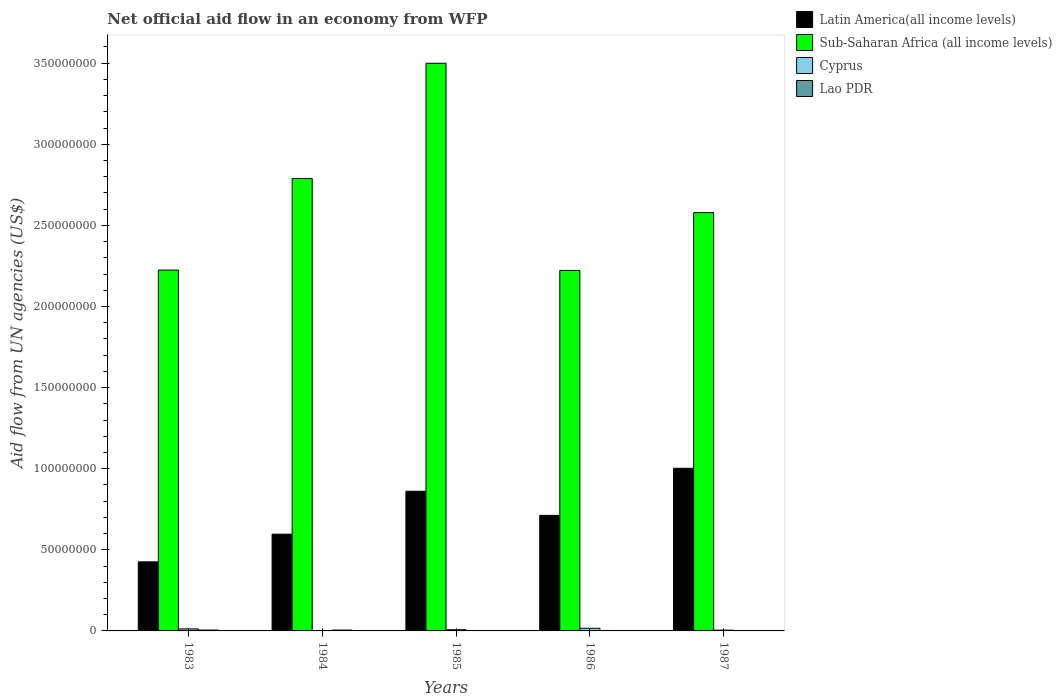How many different coloured bars are there?
Your answer should be compact. 4. How many groups of bars are there?
Provide a short and direct response. 5. What is the label of the 4th group of bars from the left?
Your response must be concise. 1986. In how many cases, is the number of bars for a given year not equal to the number of legend labels?
Your answer should be compact. 0. What is the net official aid flow in Cyprus in 1985?
Ensure brevity in your answer.  7.40e+05. Across all years, what is the maximum net official aid flow in Cyprus?
Offer a terse response. 1.63e+06. Across all years, what is the minimum net official aid flow in Cyprus?
Your answer should be compact. 2.20e+05. In which year was the net official aid flow in Sub-Saharan Africa (all income levels) minimum?
Give a very brief answer. 1986. What is the total net official aid flow in Lao PDR in the graph?
Your answer should be compact. 1.74e+06. What is the difference between the net official aid flow in Sub-Saharan Africa (all income levels) in 1983 and that in 1984?
Keep it short and to the point. -5.64e+07. What is the difference between the net official aid flow in Latin America(all income levels) in 1987 and the net official aid flow in Lao PDR in 1985?
Give a very brief answer. 1.00e+08. What is the average net official aid flow in Latin America(all income levels) per year?
Your response must be concise. 7.20e+07. In the year 1987, what is the difference between the net official aid flow in Latin America(all income levels) and net official aid flow in Sub-Saharan Africa (all income levels)?
Ensure brevity in your answer.  -1.58e+08. In how many years, is the net official aid flow in Sub-Saharan Africa (all income levels) greater than 50000000 US$?
Keep it short and to the point. 5. What is the ratio of the net official aid flow in Latin America(all income levels) in 1983 to that in 1987?
Provide a succinct answer. 0.42. Is the difference between the net official aid flow in Latin America(all income levels) in 1985 and 1987 greater than the difference between the net official aid flow in Sub-Saharan Africa (all income levels) in 1985 and 1987?
Your answer should be compact. No. What is the difference between the highest and the second highest net official aid flow in Lao PDR?
Provide a short and direct response. 10000. In how many years, is the net official aid flow in Latin America(all income levels) greater than the average net official aid flow in Latin America(all income levels) taken over all years?
Your response must be concise. 2. Is the sum of the net official aid flow in Sub-Saharan Africa (all income levels) in 1983 and 1984 greater than the maximum net official aid flow in Cyprus across all years?
Provide a succinct answer. Yes. What does the 3rd bar from the left in 1984 represents?
Give a very brief answer. Cyprus. What does the 1st bar from the right in 1983 represents?
Provide a short and direct response. Lao PDR. Is it the case that in every year, the sum of the net official aid flow in Latin America(all income levels) and net official aid flow in Cyprus is greater than the net official aid flow in Sub-Saharan Africa (all income levels)?
Your answer should be very brief. No. How many bars are there?
Make the answer very short. 20. Are all the bars in the graph horizontal?
Ensure brevity in your answer.  No. What is the difference between two consecutive major ticks on the Y-axis?
Ensure brevity in your answer.  5.00e+07. Are the values on the major ticks of Y-axis written in scientific E-notation?
Provide a succinct answer. No. Does the graph contain any zero values?
Make the answer very short. No. Where does the legend appear in the graph?
Provide a succinct answer. Top right. How many legend labels are there?
Make the answer very short. 4. How are the legend labels stacked?
Your response must be concise. Vertical. What is the title of the graph?
Keep it short and to the point. Net official aid flow in an economy from WFP. Does "Sint Maarten (Dutch part)" appear as one of the legend labels in the graph?
Ensure brevity in your answer.  No. What is the label or title of the X-axis?
Make the answer very short. Years. What is the label or title of the Y-axis?
Offer a terse response. Aid flow from UN agencies (US$). What is the Aid flow from UN agencies (US$) of Latin America(all income levels) in 1983?
Keep it short and to the point. 4.26e+07. What is the Aid flow from UN agencies (US$) in Sub-Saharan Africa (all income levels) in 1983?
Make the answer very short. 2.22e+08. What is the Aid flow from UN agencies (US$) in Cyprus in 1983?
Give a very brief answer. 1.25e+06. What is the Aid flow from UN agencies (US$) of Lao PDR in 1983?
Make the answer very short. 5.30e+05. What is the Aid flow from UN agencies (US$) of Latin America(all income levels) in 1984?
Make the answer very short. 5.96e+07. What is the Aid flow from UN agencies (US$) of Sub-Saharan Africa (all income levels) in 1984?
Make the answer very short. 2.79e+08. What is the Aid flow from UN agencies (US$) in Lao PDR in 1984?
Provide a succinct answer. 5.20e+05. What is the Aid flow from UN agencies (US$) in Latin America(all income levels) in 1985?
Give a very brief answer. 8.61e+07. What is the Aid flow from UN agencies (US$) of Sub-Saharan Africa (all income levels) in 1985?
Make the answer very short. 3.50e+08. What is the Aid flow from UN agencies (US$) in Cyprus in 1985?
Provide a short and direct response. 7.40e+05. What is the Aid flow from UN agencies (US$) of Latin America(all income levels) in 1986?
Your answer should be compact. 7.12e+07. What is the Aid flow from UN agencies (US$) of Sub-Saharan Africa (all income levels) in 1986?
Your response must be concise. 2.22e+08. What is the Aid flow from UN agencies (US$) in Cyprus in 1986?
Provide a succinct answer. 1.63e+06. What is the Aid flow from UN agencies (US$) in Lao PDR in 1986?
Ensure brevity in your answer.  2.60e+05. What is the Aid flow from UN agencies (US$) in Latin America(all income levels) in 1987?
Your answer should be very brief. 1.00e+08. What is the Aid flow from UN agencies (US$) in Sub-Saharan Africa (all income levels) in 1987?
Ensure brevity in your answer.  2.58e+08. What is the Aid flow from UN agencies (US$) in Cyprus in 1987?
Make the answer very short. 4.80e+05. Across all years, what is the maximum Aid flow from UN agencies (US$) of Latin America(all income levels)?
Offer a terse response. 1.00e+08. Across all years, what is the maximum Aid flow from UN agencies (US$) in Sub-Saharan Africa (all income levels)?
Your answer should be very brief. 3.50e+08. Across all years, what is the maximum Aid flow from UN agencies (US$) of Cyprus?
Provide a succinct answer. 1.63e+06. Across all years, what is the maximum Aid flow from UN agencies (US$) in Lao PDR?
Provide a short and direct response. 5.30e+05. Across all years, what is the minimum Aid flow from UN agencies (US$) of Latin America(all income levels)?
Offer a very short reply. 4.26e+07. Across all years, what is the minimum Aid flow from UN agencies (US$) in Sub-Saharan Africa (all income levels)?
Provide a succinct answer. 2.22e+08. What is the total Aid flow from UN agencies (US$) in Latin America(all income levels) in the graph?
Provide a succinct answer. 3.60e+08. What is the total Aid flow from UN agencies (US$) of Sub-Saharan Africa (all income levels) in the graph?
Offer a terse response. 1.33e+09. What is the total Aid flow from UN agencies (US$) of Cyprus in the graph?
Provide a succinct answer. 4.32e+06. What is the total Aid flow from UN agencies (US$) in Lao PDR in the graph?
Provide a short and direct response. 1.74e+06. What is the difference between the Aid flow from UN agencies (US$) of Latin America(all income levels) in 1983 and that in 1984?
Ensure brevity in your answer.  -1.71e+07. What is the difference between the Aid flow from UN agencies (US$) in Sub-Saharan Africa (all income levels) in 1983 and that in 1984?
Keep it short and to the point. -5.64e+07. What is the difference between the Aid flow from UN agencies (US$) of Cyprus in 1983 and that in 1984?
Provide a short and direct response. 1.03e+06. What is the difference between the Aid flow from UN agencies (US$) in Lao PDR in 1983 and that in 1984?
Keep it short and to the point. 10000. What is the difference between the Aid flow from UN agencies (US$) of Latin America(all income levels) in 1983 and that in 1985?
Ensure brevity in your answer.  -4.35e+07. What is the difference between the Aid flow from UN agencies (US$) in Sub-Saharan Africa (all income levels) in 1983 and that in 1985?
Make the answer very short. -1.27e+08. What is the difference between the Aid flow from UN agencies (US$) in Cyprus in 1983 and that in 1985?
Give a very brief answer. 5.10e+05. What is the difference between the Aid flow from UN agencies (US$) in Lao PDR in 1983 and that in 1985?
Offer a very short reply. 3.50e+05. What is the difference between the Aid flow from UN agencies (US$) of Latin America(all income levels) in 1983 and that in 1986?
Make the answer very short. -2.87e+07. What is the difference between the Aid flow from UN agencies (US$) of Sub-Saharan Africa (all income levels) in 1983 and that in 1986?
Your response must be concise. 2.30e+05. What is the difference between the Aid flow from UN agencies (US$) of Cyprus in 1983 and that in 1986?
Your response must be concise. -3.80e+05. What is the difference between the Aid flow from UN agencies (US$) of Lao PDR in 1983 and that in 1986?
Your answer should be compact. 2.70e+05. What is the difference between the Aid flow from UN agencies (US$) in Latin America(all income levels) in 1983 and that in 1987?
Provide a succinct answer. -5.77e+07. What is the difference between the Aid flow from UN agencies (US$) of Sub-Saharan Africa (all income levels) in 1983 and that in 1987?
Your answer should be compact. -3.54e+07. What is the difference between the Aid flow from UN agencies (US$) of Cyprus in 1983 and that in 1987?
Make the answer very short. 7.70e+05. What is the difference between the Aid flow from UN agencies (US$) of Latin America(all income levels) in 1984 and that in 1985?
Give a very brief answer. -2.65e+07. What is the difference between the Aid flow from UN agencies (US$) of Sub-Saharan Africa (all income levels) in 1984 and that in 1985?
Provide a succinct answer. -7.10e+07. What is the difference between the Aid flow from UN agencies (US$) in Cyprus in 1984 and that in 1985?
Your answer should be compact. -5.20e+05. What is the difference between the Aid flow from UN agencies (US$) of Lao PDR in 1984 and that in 1985?
Keep it short and to the point. 3.40e+05. What is the difference between the Aid flow from UN agencies (US$) in Latin America(all income levels) in 1984 and that in 1986?
Your answer should be compact. -1.16e+07. What is the difference between the Aid flow from UN agencies (US$) in Sub-Saharan Africa (all income levels) in 1984 and that in 1986?
Your response must be concise. 5.67e+07. What is the difference between the Aid flow from UN agencies (US$) in Cyprus in 1984 and that in 1986?
Your answer should be very brief. -1.41e+06. What is the difference between the Aid flow from UN agencies (US$) in Latin America(all income levels) in 1984 and that in 1987?
Ensure brevity in your answer.  -4.06e+07. What is the difference between the Aid flow from UN agencies (US$) of Sub-Saharan Africa (all income levels) in 1984 and that in 1987?
Provide a short and direct response. 2.11e+07. What is the difference between the Aid flow from UN agencies (US$) in Cyprus in 1984 and that in 1987?
Provide a short and direct response. -2.60e+05. What is the difference between the Aid flow from UN agencies (US$) in Lao PDR in 1984 and that in 1987?
Offer a terse response. 2.70e+05. What is the difference between the Aid flow from UN agencies (US$) of Latin America(all income levels) in 1985 and that in 1986?
Make the answer very short. 1.49e+07. What is the difference between the Aid flow from UN agencies (US$) in Sub-Saharan Africa (all income levels) in 1985 and that in 1986?
Offer a terse response. 1.28e+08. What is the difference between the Aid flow from UN agencies (US$) of Cyprus in 1985 and that in 1986?
Provide a succinct answer. -8.90e+05. What is the difference between the Aid flow from UN agencies (US$) in Latin America(all income levels) in 1985 and that in 1987?
Your answer should be very brief. -1.42e+07. What is the difference between the Aid flow from UN agencies (US$) of Sub-Saharan Africa (all income levels) in 1985 and that in 1987?
Offer a very short reply. 9.21e+07. What is the difference between the Aid flow from UN agencies (US$) in Latin America(all income levels) in 1986 and that in 1987?
Offer a very short reply. -2.90e+07. What is the difference between the Aid flow from UN agencies (US$) of Sub-Saharan Africa (all income levels) in 1986 and that in 1987?
Provide a short and direct response. -3.56e+07. What is the difference between the Aid flow from UN agencies (US$) of Cyprus in 1986 and that in 1987?
Ensure brevity in your answer.  1.15e+06. What is the difference between the Aid flow from UN agencies (US$) of Latin America(all income levels) in 1983 and the Aid flow from UN agencies (US$) of Sub-Saharan Africa (all income levels) in 1984?
Offer a terse response. -2.36e+08. What is the difference between the Aid flow from UN agencies (US$) of Latin America(all income levels) in 1983 and the Aid flow from UN agencies (US$) of Cyprus in 1984?
Provide a succinct answer. 4.24e+07. What is the difference between the Aid flow from UN agencies (US$) in Latin America(all income levels) in 1983 and the Aid flow from UN agencies (US$) in Lao PDR in 1984?
Provide a succinct answer. 4.21e+07. What is the difference between the Aid flow from UN agencies (US$) in Sub-Saharan Africa (all income levels) in 1983 and the Aid flow from UN agencies (US$) in Cyprus in 1984?
Offer a very short reply. 2.22e+08. What is the difference between the Aid flow from UN agencies (US$) of Sub-Saharan Africa (all income levels) in 1983 and the Aid flow from UN agencies (US$) of Lao PDR in 1984?
Your answer should be compact. 2.22e+08. What is the difference between the Aid flow from UN agencies (US$) in Cyprus in 1983 and the Aid flow from UN agencies (US$) in Lao PDR in 1984?
Provide a succinct answer. 7.30e+05. What is the difference between the Aid flow from UN agencies (US$) of Latin America(all income levels) in 1983 and the Aid flow from UN agencies (US$) of Sub-Saharan Africa (all income levels) in 1985?
Your answer should be compact. -3.07e+08. What is the difference between the Aid flow from UN agencies (US$) of Latin America(all income levels) in 1983 and the Aid flow from UN agencies (US$) of Cyprus in 1985?
Provide a short and direct response. 4.18e+07. What is the difference between the Aid flow from UN agencies (US$) in Latin America(all income levels) in 1983 and the Aid flow from UN agencies (US$) in Lao PDR in 1985?
Provide a succinct answer. 4.24e+07. What is the difference between the Aid flow from UN agencies (US$) of Sub-Saharan Africa (all income levels) in 1983 and the Aid flow from UN agencies (US$) of Cyprus in 1985?
Your response must be concise. 2.22e+08. What is the difference between the Aid flow from UN agencies (US$) of Sub-Saharan Africa (all income levels) in 1983 and the Aid flow from UN agencies (US$) of Lao PDR in 1985?
Make the answer very short. 2.22e+08. What is the difference between the Aid flow from UN agencies (US$) of Cyprus in 1983 and the Aid flow from UN agencies (US$) of Lao PDR in 1985?
Your answer should be very brief. 1.07e+06. What is the difference between the Aid flow from UN agencies (US$) of Latin America(all income levels) in 1983 and the Aid flow from UN agencies (US$) of Sub-Saharan Africa (all income levels) in 1986?
Your answer should be compact. -1.80e+08. What is the difference between the Aid flow from UN agencies (US$) of Latin America(all income levels) in 1983 and the Aid flow from UN agencies (US$) of Cyprus in 1986?
Keep it short and to the point. 4.10e+07. What is the difference between the Aid flow from UN agencies (US$) in Latin America(all income levels) in 1983 and the Aid flow from UN agencies (US$) in Lao PDR in 1986?
Your answer should be compact. 4.23e+07. What is the difference between the Aid flow from UN agencies (US$) in Sub-Saharan Africa (all income levels) in 1983 and the Aid flow from UN agencies (US$) in Cyprus in 1986?
Make the answer very short. 2.21e+08. What is the difference between the Aid flow from UN agencies (US$) in Sub-Saharan Africa (all income levels) in 1983 and the Aid flow from UN agencies (US$) in Lao PDR in 1986?
Provide a short and direct response. 2.22e+08. What is the difference between the Aid flow from UN agencies (US$) of Cyprus in 1983 and the Aid flow from UN agencies (US$) of Lao PDR in 1986?
Your answer should be compact. 9.90e+05. What is the difference between the Aid flow from UN agencies (US$) of Latin America(all income levels) in 1983 and the Aid flow from UN agencies (US$) of Sub-Saharan Africa (all income levels) in 1987?
Keep it short and to the point. -2.15e+08. What is the difference between the Aid flow from UN agencies (US$) of Latin America(all income levels) in 1983 and the Aid flow from UN agencies (US$) of Cyprus in 1987?
Your response must be concise. 4.21e+07. What is the difference between the Aid flow from UN agencies (US$) in Latin America(all income levels) in 1983 and the Aid flow from UN agencies (US$) in Lao PDR in 1987?
Give a very brief answer. 4.23e+07. What is the difference between the Aid flow from UN agencies (US$) in Sub-Saharan Africa (all income levels) in 1983 and the Aid flow from UN agencies (US$) in Cyprus in 1987?
Offer a terse response. 2.22e+08. What is the difference between the Aid flow from UN agencies (US$) in Sub-Saharan Africa (all income levels) in 1983 and the Aid flow from UN agencies (US$) in Lao PDR in 1987?
Make the answer very short. 2.22e+08. What is the difference between the Aid flow from UN agencies (US$) of Latin America(all income levels) in 1984 and the Aid flow from UN agencies (US$) of Sub-Saharan Africa (all income levels) in 1985?
Provide a short and direct response. -2.90e+08. What is the difference between the Aid flow from UN agencies (US$) of Latin America(all income levels) in 1984 and the Aid flow from UN agencies (US$) of Cyprus in 1985?
Ensure brevity in your answer.  5.89e+07. What is the difference between the Aid flow from UN agencies (US$) of Latin America(all income levels) in 1984 and the Aid flow from UN agencies (US$) of Lao PDR in 1985?
Provide a succinct answer. 5.95e+07. What is the difference between the Aid flow from UN agencies (US$) in Sub-Saharan Africa (all income levels) in 1984 and the Aid flow from UN agencies (US$) in Cyprus in 1985?
Keep it short and to the point. 2.78e+08. What is the difference between the Aid flow from UN agencies (US$) in Sub-Saharan Africa (all income levels) in 1984 and the Aid flow from UN agencies (US$) in Lao PDR in 1985?
Ensure brevity in your answer.  2.79e+08. What is the difference between the Aid flow from UN agencies (US$) in Cyprus in 1984 and the Aid flow from UN agencies (US$) in Lao PDR in 1985?
Give a very brief answer. 4.00e+04. What is the difference between the Aid flow from UN agencies (US$) in Latin America(all income levels) in 1984 and the Aid flow from UN agencies (US$) in Sub-Saharan Africa (all income levels) in 1986?
Provide a short and direct response. -1.63e+08. What is the difference between the Aid flow from UN agencies (US$) of Latin America(all income levels) in 1984 and the Aid flow from UN agencies (US$) of Cyprus in 1986?
Make the answer very short. 5.80e+07. What is the difference between the Aid flow from UN agencies (US$) of Latin America(all income levels) in 1984 and the Aid flow from UN agencies (US$) of Lao PDR in 1986?
Your response must be concise. 5.94e+07. What is the difference between the Aid flow from UN agencies (US$) in Sub-Saharan Africa (all income levels) in 1984 and the Aid flow from UN agencies (US$) in Cyprus in 1986?
Keep it short and to the point. 2.77e+08. What is the difference between the Aid flow from UN agencies (US$) of Sub-Saharan Africa (all income levels) in 1984 and the Aid flow from UN agencies (US$) of Lao PDR in 1986?
Give a very brief answer. 2.79e+08. What is the difference between the Aid flow from UN agencies (US$) in Latin America(all income levels) in 1984 and the Aid flow from UN agencies (US$) in Sub-Saharan Africa (all income levels) in 1987?
Keep it short and to the point. -1.98e+08. What is the difference between the Aid flow from UN agencies (US$) in Latin America(all income levels) in 1984 and the Aid flow from UN agencies (US$) in Cyprus in 1987?
Offer a very short reply. 5.92e+07. What is the difference between the Aid flow from UN agencies (US$) in Latin America(all income levels) in 1984 and the Aid flow from UN agencies (US$) in Lao PDR in 1987?
Offer a very short reply. 5.94e+07. What is the difference between the Aid flow from UN agencies (US$) of Sub-Saharan Africa (all income levels) in 1984 and the Aid flow from UN agencies (US$) of Cyprus in 1987?
Your answer should be compact. 2.78e+08. What is the difference between the Aid flow from UN agencies (US$) in Sub-Saharan Africa (all income levels) in 1984 and the Aid flow from UN agencies (US$) in Lao PDR in 1987?
Offer a terse response. 2.79e+08. What is the difference between the Aid flow from UN agencies (US$) of Cyprus in 1984 and the Aid flow from UN agencies (US$) of Lao PDR in 1987?
Provide a short and direct response. -3.00e+04. What is the difference between the Aid flow from UN agencies (US$) of Latin America(all income levels) in 1985 and the Aid flow from UN agencies (US$) of Sub-Saharan Africa (all income levels) in 1986?
Your answer should be very brief. -1.36e+08. What is the difference between the Aid flow from UN agencies (US$) of Latin America(all income levels) in 1985 and the Aid flow from UN agencies (US$) of Cyprus in 1986?
Keep it short and to the point. 8.45e+07. What is the difference between the Aid flow from UN agencies (US$) in Latin America(all income levels) in 1985 and the Aid flow from UN agencies (US$) in Lao PDR in 1986?
Offer a very short reply. 8.58e+07. What is the difference between the Aid flow from UN agencies (US$) in Sub-Saharan Africa (all income levels) in 1985 and the Aid flow from UN agencies (US$) in Cyprus in 1986?
Offer a terse response. 3.48e+08. What is the difference between the Aid flow from UN agencies (US$) of Sub-Saharan Africa (all income levels) in 1985 and the Aid flow from UN agencies (US$) of Lao PDR in 1986?
Keep it short and to the point. 3.50e+08. What is the difference between the Aid flow from UN agencies (US$) of Latin America(all income levels) in 1985 and the Aid flow from UN agencies (US$) of Sub-Saharan Africa (all income levels) in 1987?
Offer a very short reply. -1.72e+08. What is the difference between the Aid flow from UN agencies (US$) of Latin America(all income levels) in 1985 and the Aid flow from UN agencies (US$) of Cyprus in 1987?
Your answer should be very brief. 8.56e+07. What is the difference between the Aid flow from UN agencies (US$) of Latin America(all income levels) in 1985 and the Aid flow from UN agencies (US$) of Lao PDR in 1987?
Offer a terse response. 8.59e+07. What is the difference between the Aid flow from UN agencies (US$) in Sub-Saharan Africa (all income levels) in 1985 and the Aid flow from UN agencies (US$) in Cyprus in 1987?
Offer a terse response. 3.49e+08. What is the difference between the Aid flow from UN agencies (US$) in Sub-Saharan Africa (all income levels) in 1985 and the Aid flow from UN agencies (US$) in Lao PDR in 1987?
Offer a terse response. 3.50e+08. What is the difference between the Aid flow from UN agencies (US$) of Latin America(all income levels) in 1986 and the Aid flow from UN agencies (US$) of Sub-Saharan Africa (all income levels) in 1987?
Make the answer very short. -1.87e+08. What is the difference between the Aid flow from UN agencies (US$) of Latin America(all income levels) in 1986 and the Aid flow from UN agencies (US$) of Cyprus in 1987?
Offer a terse response. 7.08e+07. What is the difference between the Aid flow from UN agencies (US$) in Latin America(all income levels) in 1986 and the Aid flow from UN agencies (US$) in Lao PDR in 1987?
Keep it short and to the point. 7.10e+07. What is the difference between the Aid flow from UN agencies (US$) of Sub-Saharan Africa (all income levels) in 1986 and the Aid flow from UN agencies (US$) of Cyprus in 1987?
Keep it short and to the point. 2.22e+08. What is the difference between the Aid flow from UN agencies (US$) of Sub-Saharan Africa (all income levels) in 1986 and the Aid flow from UN agencies (US$) of Lao PDR in 1987?
Provide a succinct answer. 2.22e+08. What is the difference between the Aid flow from UN agencies (US$) of Cyprus in 1986 and the Aid flow from UN agencies (US$) of Lao PDR in 1987?
Offer a very short reply. 1.38e+06. What is the average Aid flow from UN agencies (US$) of Latin America(all income levels) per year?
Your response must be concise. 7.20e+07. What is the average Aid flow from UN agencies (US$) of Sub-Saharan Africa (all income levels) per year?
Offer a terse response. 2.66e+08. What is the average Aid flow from UN agencies (US$) in Cyprus per year?
Your answer should be very brief. 8.64e+05. What is the average Aid flow from UN agencies (US$) in Lao PDR per year?
Make the answer very short. 3.48e+05. In the year 1983, what is the difference between the Aid flow from UN agencies (US$) of Latin America(all income levels) and Aid flow from UN agencies (US$) of Sub-Saharan Africa (all income levels)?
Your answer should be very brief. -1.80e+08. In the year 1983, what is the difference between the Aid flow from UN agencies (US$) of Latin America(all income levels) and Aid flow from UN agencies (US$) of Cyprus?
Your response must be concise. 4.13e+07. In the year 1983, what is the difference between the Aid flow from UN agencies (US$) in Latin America(all income levels) and Aid flow from UN agencies (US$) in Lao PDR?
Your answer should be very brief. 4.20e+07. In the year 1983, what is the difference between the Aid flow from UN agencies (US$) of Sub-Saharan Africa (all income levels) and Aid flow from UN agencies (US$) of Cyprus?
Offer a terse response. 2.21e+08. In the year 1983, what is the difference between the Aid flow from UN agencies (US$) of Sub-Saharan Africa (all income levels) and Aid flow from UN agencies (US$) of Lao PDR?
Your response must be concise. 2.22e+08. In the year 1983, what is the difference between the Aid flow from UN agencies (US$) of Cyprus and Aid flow from UN agencies (US$) of Lao PDR?
Your answer should be very brief. 7.20e+05. In the year 1984, what is the difference between the Aid flow from UN agencies (US$) in Latin America(all income levels) and Aid flow from UN agencies (US$) in Sub-Saharan Africa (all income levels)?
Offer a terse response. -2.19e+08. In the year 1984, what is the difference between the Aid flow from UN agencies (US$) in Latin America(all income levels) and Aid flow from UN agencies (US$) in Cyprus?
Your answer should be very brief. 5.94e+07. In the year 1984, what is the difference between the Aid flow from UN agencies (US$) in Latin America(all income levels) and Aid flow from UN agencies (US$) in Lao PDR?
Give a very brief answer. 5.91e+07. In the year 1984, what is the difference between the Aid flow from UN agencies (US$) in Sub-Saharan Africa (all income levels) and Aid flow from UN agencies (US$) in Cyprus?
Make the answer very short. 2.79e+08. In the year 1984, what is the difference between the Aid flow from UN agencies (US$) of Sub-Saharan Africa (all income levels) and Aid flow from UN agencies (US$) of Lao PDR?
Offer a very short reply. 2.78e+08. In the year 1985, what is the difference between the Aid flow from UN agencies (US$) in Latin America(all income levels) and Aid flow from UN agencies (US$) in Sub-Saharan Africa (all income levels)?
Your response must be concise. -2.64e+08. In the year 1985, what is the difference between the Aid flow from UN agencies (US$) in Latin America(all income levels) and Aid flow from UN agencies (US$) in Cyprus?
Ensure brevity in your answer.  8.54e+07. In the year 1985, what is the difference between the Aid flow from UN agencies (US$) of Latin America(all income levels) and Aid flow from UN agencies (US$) of Lao PDR?
Your answer should be very brief. 8.59e+07. In the year 1985, what is the difference between the Aid flow from UN agencies (US$) in Sub-Saharan Africa (all income levels) and Aid flow from UN agencies (US$) in Cyprus?
Provide a short and direct response. 3.49e+08. In the year 1985, what is the difference between the Aid flow from UN agencies (US$) of Sub-Saharan Africa (all income levels) and Aid flow from UN agencies (US$) of Lao PDR?
Offer a terse response. 3.50e+08. In the year 1985, what is the difference between the Aid flow from UN agencies (US$) in Cyprus and Aid flow from UN agencies (US$) in Lao PDR?
Offer a terse response. 5.60e+05. In the year 1986, what is the difference between the Aid flow from UN agencies (US$) in Latin America(all income levels) and Aid flow from UN agencies (US$) in Sub-Saharan Africa (all income levels)?
Your answer should be very brief. -1.51e+08. In the year 1986, what is the difference between the Aid flow from UN agencies (US$) in Latin America(all income levels) and Aid flow from UN agencies (US$) in Cyprus?
Your answer should be very brief. 6.96e+07. In the year 1986, what is the difference between the Aid flow from UN agencies (US$) of Latin America(all income levels) and Aid flow from UN agencies (US$) of Lao PDR?
Your response must be concise. 7.10e+07. In the year 1986, what is the difference between the Aid flow from UN agencies (US$) in Sub-Saharan Africa (all income levels) and Aid flow from UN agencies (US$) in Cyprus?
Provide a short and direct response. 2.21e+08. In the year 1986, what is the difference between the Aid flow from UN agencies (US$) of Sub-Saharan Africa (all income levels) and Aid flow from UN agencies (US$) of Lao PDR?
Offer a very short reply. 2.22e+08. In the year 1986, what is the difference between the Aid flow from UN agencies (US$) of Cyprus and Aid flow from UN agencies (US$) of Lao PDR?
Offer a very short reply. 1.37e+06. In the year 1987, what is the difference between the Aid flow from UN agencies (US$) of Latin America(all income levels) and Aid flow from UN agencies (US$) of Sub-Saharan Africa (all income levels)?
Your answer should be compact. -1.58e+08. In the year 1987, what is the difference between the Aid flow from UN agencies (US$) in Latin America(all income levels) and Aid flow from UN agencies (US$) in Cyprus?
Your answer should be compact. 9.98e+07. In the year 1987, what is the difference between the Aid flow from UN agencies (US$) in Latin America(all income levels) and Aid flow from UN agencies (US$) in Lao PDR?
Your answer should be very brief. 1.00e+08. In the year 1987, what is the difference between the Aid flow from UN agencies (US$) of Sub-Saharan Africa (all income levels) and Aid flow from UN agencies (US$) of Cyprus?
Ensure brevity in your answer.  2.57e+08. In the year 1987, what is the difference between the Aid flow from UN agencies (US$) in Sub-Saharan Africa (all income levels) and Aid flow from UN agencies (US$) in Lao PDR?
Provide a succinct answer. 2.58e+08. What is the ratio of the Aid flow from UN agencies (US$) in Latin America(all income levels) in 1983 to that in 1984?
Offer a very short reply. 0.71. What is the ratio of the Aid flow from UN agencies (US$) in Sub-Saharan Africa (all income levels) in 1983 to that in 1984?
Give a very brief answer. 0.8. What is the ratio of the Aid flow from UN agencies (US$) of Cyprus in 1983 to that in 1984?
Keep it short and to the point. 5.68. What is the ratio of the Aid flow from UN agencies (US$) of Lao PDR in 1983 to that in 1984?
Keep it short and to the point. 1.02. What is the ratio of the Aid flow from UN agencies (US$) in Latin America(all income levels) in 1983 to that in 1985?
Offer a very short reply. 0.49. What is the ratio of the Aid flow from UN agencies (US$) in Sub-Saharan Africa (all income levels) in 1983 to that in 1985?
Your answer should be compact. 0.64. What is the ratio of the Aid flow from UN agencies (US$) in Cyprus in 1983 to that in 1985?
Offer a very short reply. 1.69. What is the ratio of the Aid flow from UN agencies (US$) in Lao PDR in 1983 to that in 1985?
Keep it short and to the point. 2.94. What is the ratio of the Aid flow from UN agencies (US$) of Latin America(all income levels) in 1983 to that in 1986?
Offer a very short reply. 0.6. What is the ratio of the Aid flow from UN agencies (US$) in Sub-Saharan Africa (all income levels) in 1983 to that in 1986?
Offer a terse response. 1. What is the ratio of the Aid flow from UN agencies (US$) of Cyprus in 1983 to that in 1986?
Give a very brief answer. 0.77. What is the ratio of the Aid flow from UN agencies (US$) of Lao PDR in 1983 to that in 1986?
Your answer should be very brief. 2.04. What is the ratio of the Aid flow from UN agencies (US$) in Latin America(all income levels) in 1983 to that in 1987?
Offer a terse response. 0.42. What is the ratio of the Aid flow from UN agencies (US$) in Sub-Saharan Africa (all income levels) in 1983 to that in 1987?
Provide a short and direct response. 0.86. What is the ratio of the Aid flow from UN agencies (US$) in Cyprus in 1983 to that in 1987?
Offer a terse response. 2.6. What is the ratio of the Aid flow from UN agencies (US$) in Lao PDR in 1983 to that in 1987?
Give a very brief answer. 2.12. What is the ratio of the Aid flow from UN agencies (US$) of Latin America(all income levels) in 1984 to that in 1985?
Keep it short and to the point. 0.69. What is the ratio of the Aid flow from UN agencies (US$) in Sub-Saharan Africa (all income levels) in 1984 to that in 1985?
Give a very brief answer. 0.8. What is the ratio of the Aid flow from UN agencies (US$) in Cyprus in 1984 to that in 1985?
Keep it short and to the point. 0.3. What is the ratio of the Aid flow from UN agencies (US$) of Lao PDR in 1984 to that in 1985?
Keep it short and to the point. 2.89. What is the ratio of the Aid flow from UN agencies (US$) of Latin America(all income levels) in 1984 to that in 1986?
Provide a short and direct response. 0.84. What is the ratio of the Aid flow from UN agencies (US$) in Sub-Saharan Africa (all income levels) in 1984 to that in 1986?
Your answer should be compact. 1.25. What is the ratio of the Aid flow from UN agencies (US$) in Cyprus in 1984 to that in 1986?
Keep it short and to the point. 0.14. What is the ratio of the Aid flow from UN agencies (US$) of Lao PDR in 1984 to that in 1986?
Keep it short and to the point. 2. What is the ratio of the Aid flow from UN agencies (US$) in Latin America(all income levels) in 1984 to that in 1987?
Offer a terse response. 0.59. What is the ratio of the Aid flow from UN agencies (US$) of Sub-Saharan Africa (all income levels) in 1984 to that in 1987?
Give a very brief answer. 1.08. What is the ratio of the Aid flow from UN agencies (US$) in Cyprus in 1984 to that in 1987?
Offer a very short reply. 0.46. What is the ratio of the Aid flow from UN agencies (US$) of Lao PDR in 1984 to that in 1987?
Offer a very short reply. 2.08. What is the ratio of the Aid flow from UN agencies (US$) of Latin America(all income levels) in 1985 to that in 1986?
Give a very brief answer. 1.21. What is the ratio of the Aid flow from UN agencies (US$) of Sub-Saharan Africa (all income levels) in 1985 to that in 1986?
Your response must be concise. 1.57. What is the ratio of the Aid flow from UN agencies (US$) of Cyprus in 1985 to that in 1986?
Give a very brief answer. 0.45. What is the ratio of the Aid flow from UN agencies (US$) in Lao PDR in 1985 to that in 1986?
Your response must be concise. 0.69. What is the ratio of the Aid flow from UN agencies (US$) of Latin America(all income levels) in 1985 to that in 1987?
Your response must be concise. 0.86. What is the ratio of the Aid flow from UN agencies (US$) of Sub-Saharan Africa (all income levels) in 1985 to that in 1987?
Your answer should be compact. 1.36. What is the ratio of the Aid flow from UN agencies (US$) of Cyprus in 1985 to that in 1987?
Offer a terse response. 1.54. What is the ratio of the Aid flow from UN agencies (US$) of Lao PDR in 1985 to that in 1987?
Offer a terse response. 0.72. What is the ratio of the Aid flow from UN agencies (US$) in Latin America(all income levels) in 1986 to that in 1987?
Provide a succinct answer. 0.71. What is the ratio of the Aid flow from UN agencies (US$) in Sub-Saharan Africa (all income levels) in 1986 to that in 1987?
Your response must be concise. 0.86. What is the ratio of the Aid flow from UN agencies (US$) in Cyprus in 1986 to that in 1987?
Provide a short and direct response. 3.4. What is the ratio of the Aid flow from UN agencies (US$) in Lao PDR in 1986 to that in 1987?
Offer a terse response. 1.04. What is the difference between the highest and the second highest Aid flow from UN agencies (US$) in Latin America(all income levels)?
Give a very brief answer. 1.42e+07. What is the difference between the highest and the second highest Aid flow from UN agencies (US$) of Sub-Saharan Africa (all income levels)?
Offer a very short reply. 7.10e+07. What is the difference between the highest and the lowest Aid flow from UN agencies (US$) in Latin America(all income levels)?
Give a very brief answer. 5.77e+07. What is the difference between the highest and the lowest Aid flow from UN agencies (US$) in Sub-Saharan Africa (all income levels)?
Ensure brevity in your answer.  1.28e+08. What is the difference between the highest and the lowest Aid flow from UN agencies (US$) of Cyprus?
Your answer should be very brief. 1.41e+06. What is the difference between the highest and the lowest Aid flow from UN agencies (US$) in Lao PDR?
Your response must be concise. 3.50e+05. 